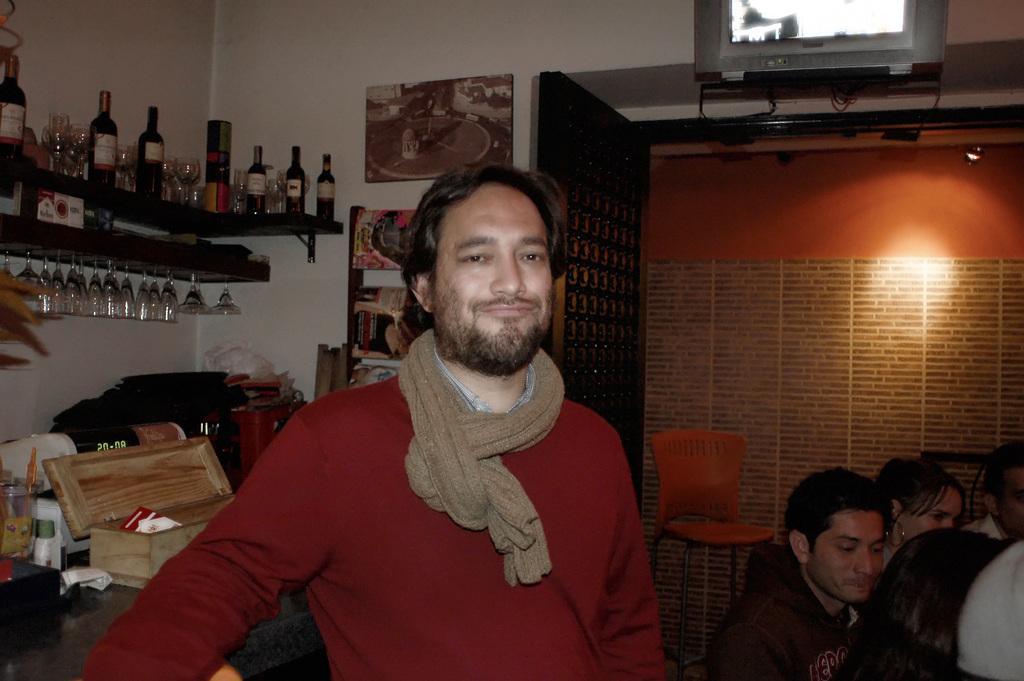Please provide a concise description of this image. This picture describes about group of people few are seated and one person is standing and he is smiling, besides to him we can see a box, glasses, clock on the table, and also we can find glasses and couple of bottles in the background. 